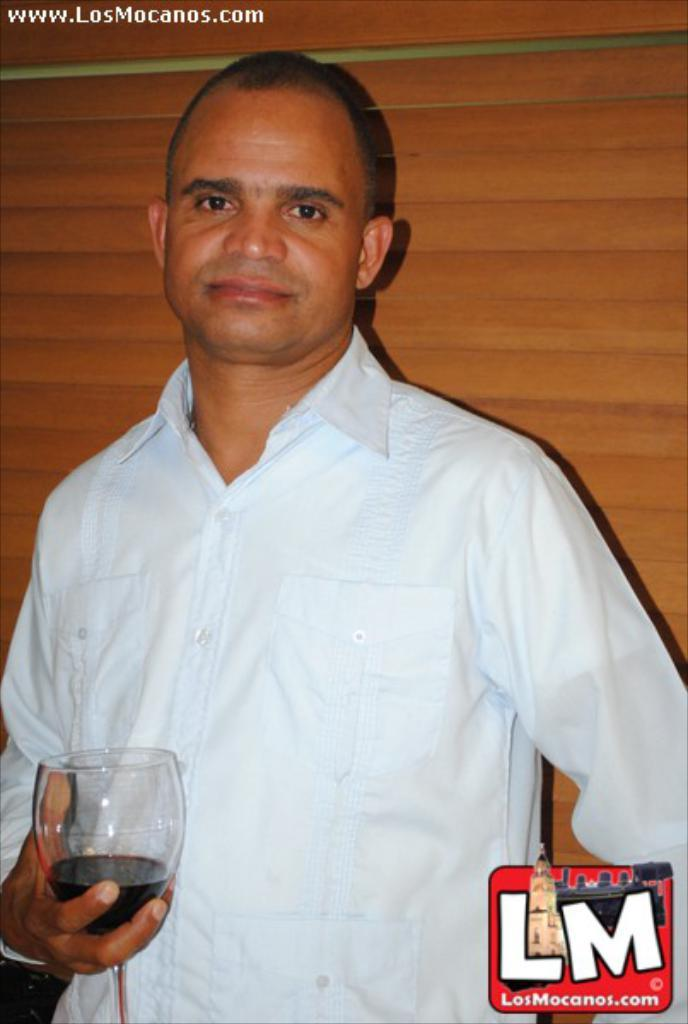Who is present in the image? There is a man in the image. What is the man holding in the image? The man is holding a glass in the image. Where is the glass located in the image? The glass is in the bottom left corner of the left corner of the image. What can be seen on the glass or near it in the image? There is a logo LM in the image. What is the man wearing in the image? The man is wearing a sky blue color shirt in the image. What time of day is it in the image, and are there any sheep present? The time of day is not mentioned in the image, and there are no sheep present in the image. 